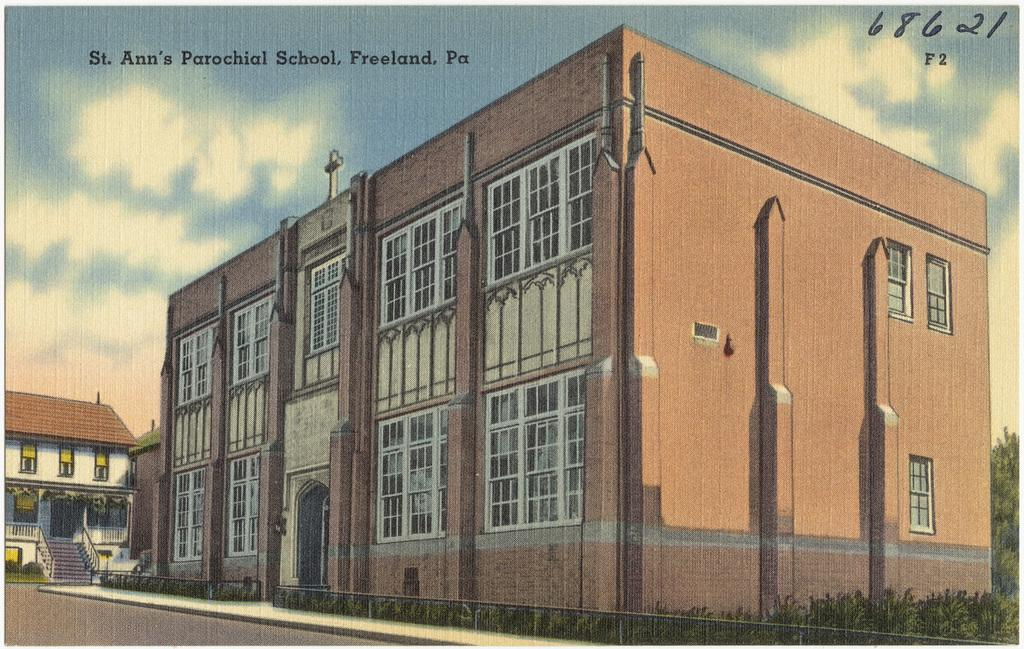Provide a one-sentence caption for the provided image. A painting of St. Ann's Parochial School which is located in Freeland, Pennsylvania. 